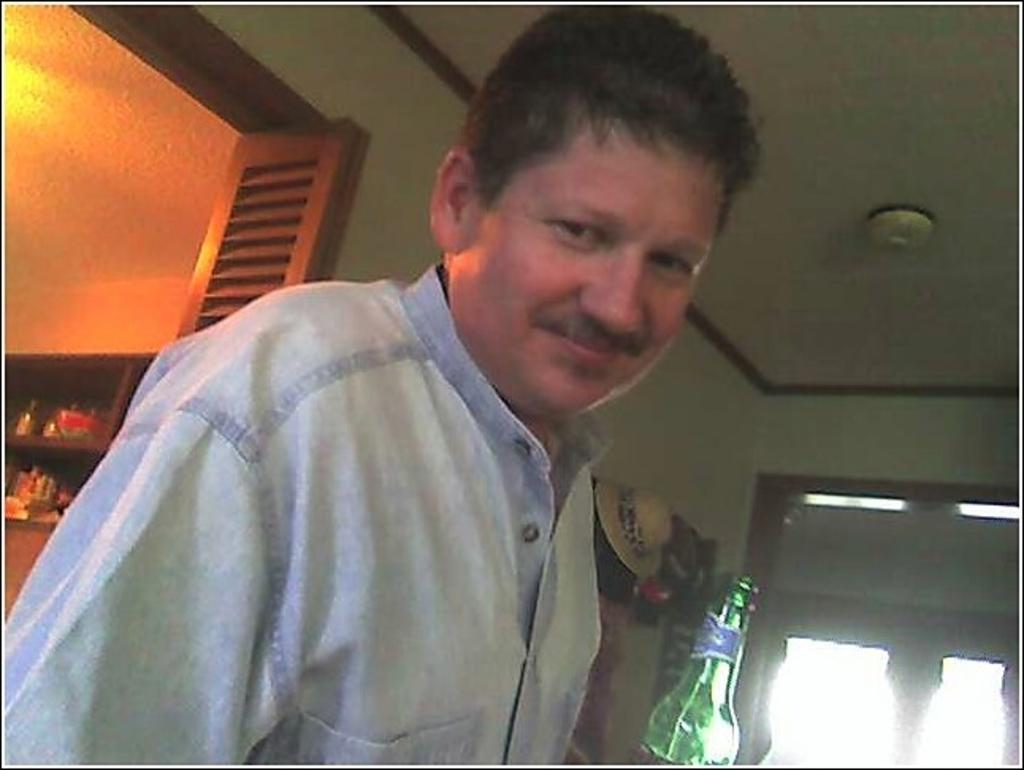Who is present in the image? There is a man in the image. What is the man's facial expression? The man is smiling. What object can be seen in the image besides the man? There is a bottle in the image. What type of decoration is on the wall in the image? There are hats on the wall in the image. What type of ring can be seen on the man's finger in the image? There is no ring visible on the man's finger in the image. Can you describe the design of the door in the image? There is no door present in the image. 